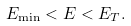<formula> <loc_0><loc_0><loc_500><loc_500>E _ { \min } < E < E _ { T } .</formula> 